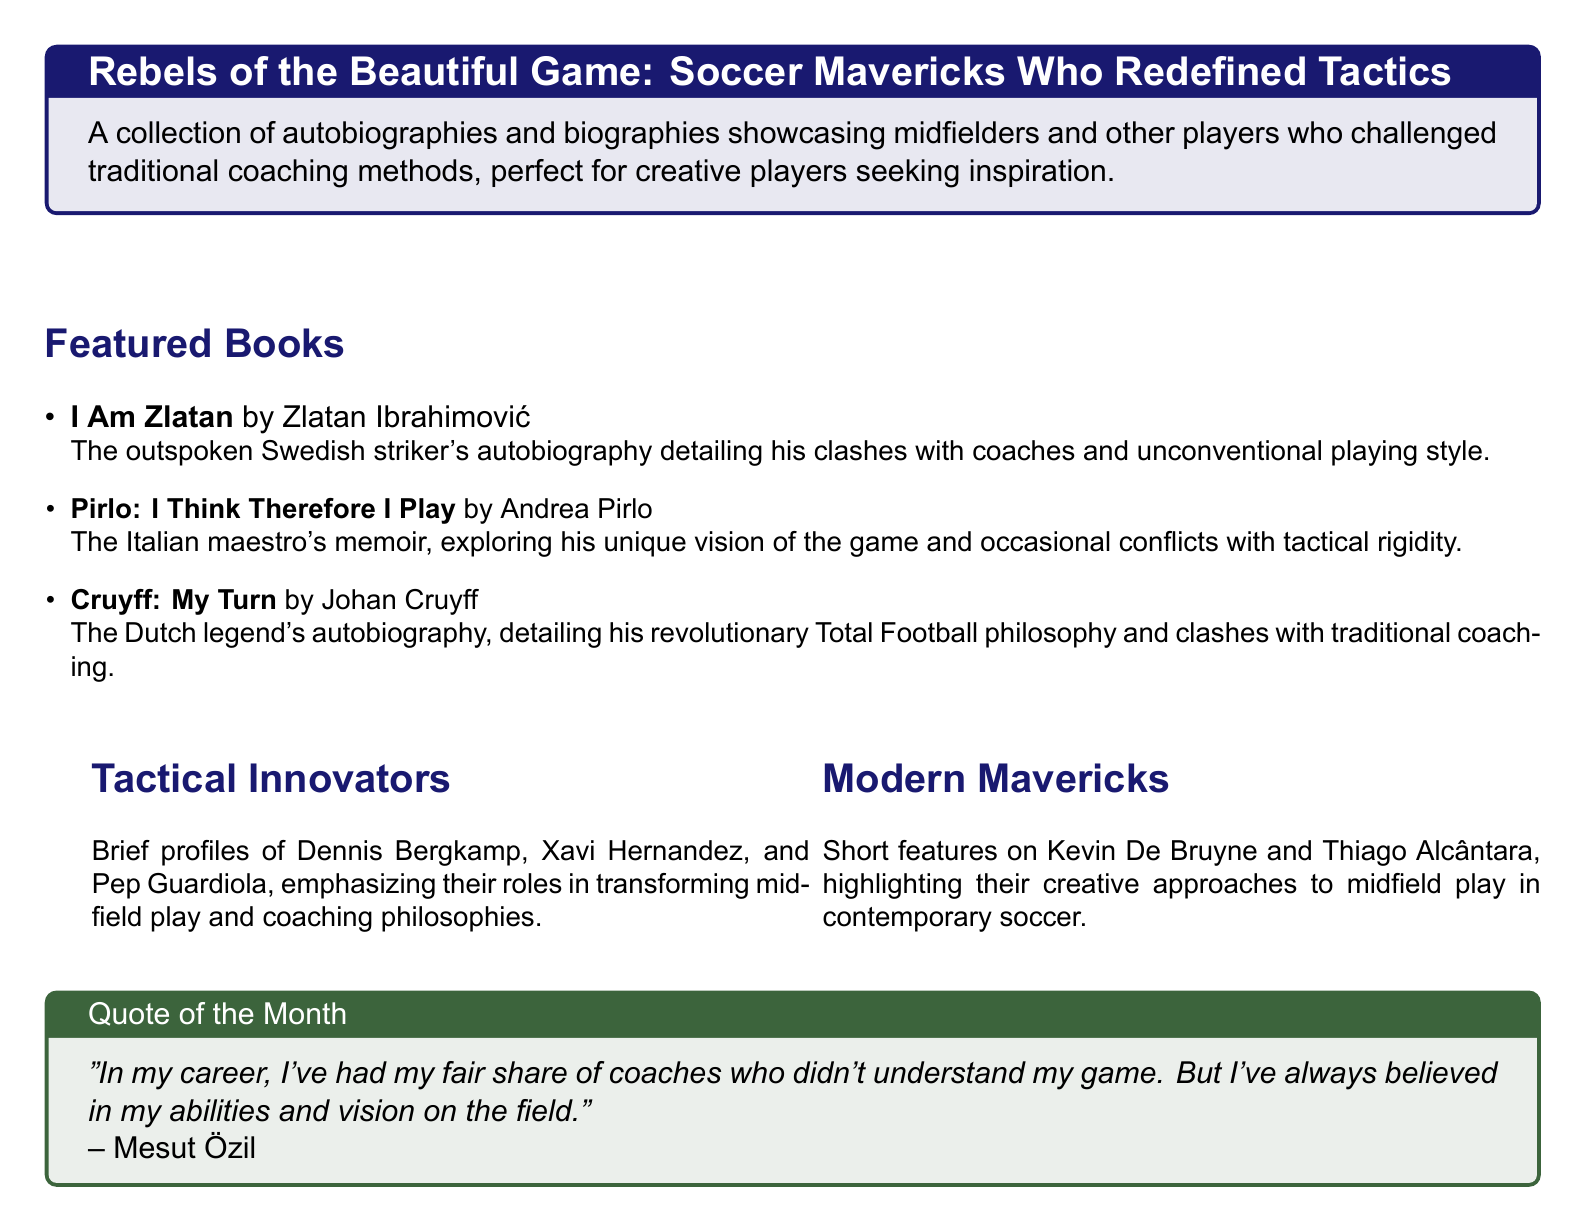What is the title of the collection? The title of the collection is explicitly mentioned in the document header, highlighting the focus on players who redefined soccer tactics.
Answer: Rebels of the Beautiful Game: Soccer Mavericks Who Redefined Tactics Who wrote "I Am Zlatan"? This is a specific detail about the featured autobiographies that can be easily found under the Featured Books section.
Answer: Zlatan Ibrahimović Which player's memoir discusses "Total Football"? The document provides information regarding each featured book, and this particular player's approach aligns with the revolutionary philosophy mentioned.
Answer: Johan Cruyff What color is used for the Quote of the Month box? The box's color is described in the document, indicating its appearance and visual structure.
Answer: Grass green Name one tactical innovator mentioned. The brief profile section lists several influential players, and this question requires recalling one name from that section.
Answer: Dennis Bergkamp Which modern maverick is highlighted for creative midfield play? The Modern Mavericks section features specific players known for their innovative approaches, and this question targets one of them.
Answer: Kevin De Bruyne How many featured books are listed? The number of books can be counted from the Featured Books section, providing an opportunity to gather quantitative information.
Answer: Three What quote is included in the document? The quote of the month is provided in the respective box, allowing for retrieval of direct textual information.
Answer: "In my career, I've had my fair share of coaches who didn't understand my game. But I've always believed in my abilities and vision on the field." 